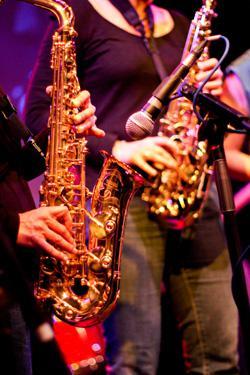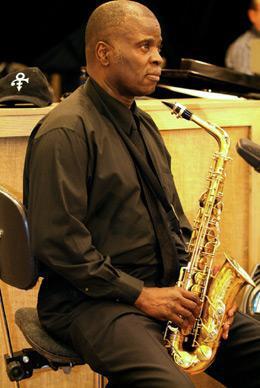The first image is the image on the left, the second image is the image on the right. Examine the images to the left and right. Is the description "An image shows an adult black male with shaved head, playing the saxophone while dressed all in black." accurate? Answer yes or no. Yes. The first image is the image on the left, the second image is the image on the right. Assess this claim about the two images: "A white man is playing a saxophone in the image on the right.". Correct or not? Answer yes or no. No. 